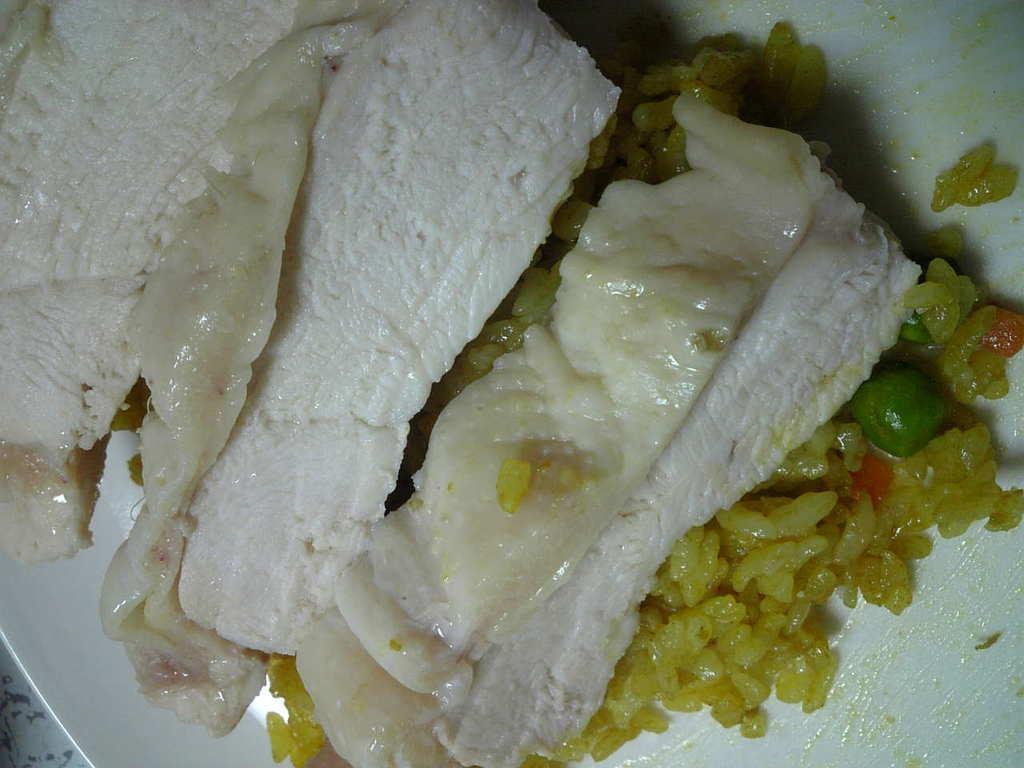How would you summarize this image in a sentence or two? There is rice and food items on a white plate. 